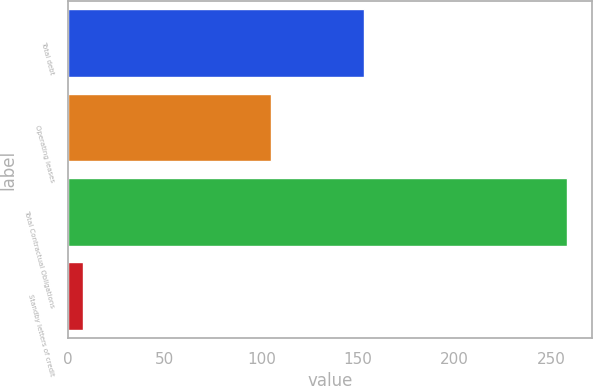<chart> <loc_0><loc_0><loc_500><loc_500><bar_chart><fcel>Total debt<fcel>Operating leases<fcel>Total Contractual Obligations<fcel>Standby letters of credit<nl><fcel>153<fcel>105<fcel>258<fcel>8<nl></chart> 